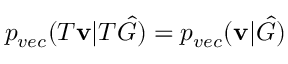Convert formula to latex. <formula><loc_0><loc_0><loc_500><loc_500>p _ { v e c } ( T v | T \hat { G } ) = p _ { v e c } ( v | \hat { G } )</formula> 